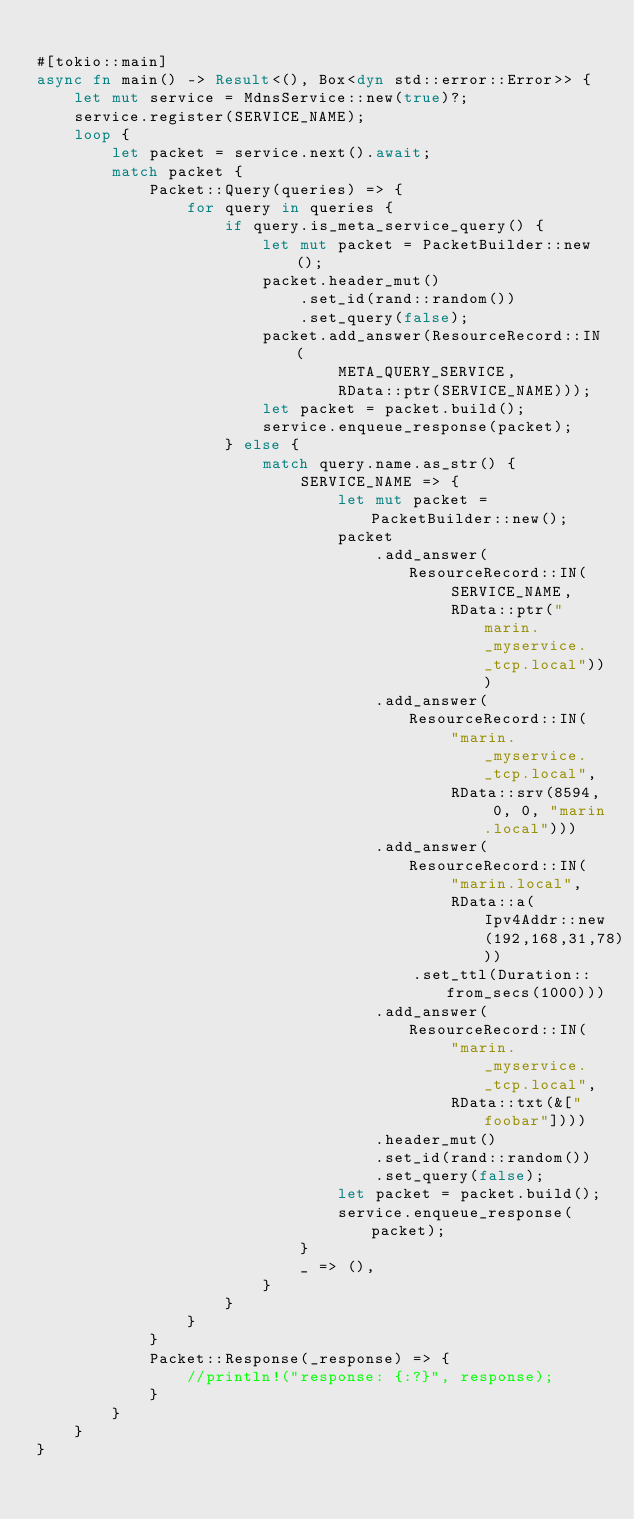Convert code to text. <code><loc_0><loc_0><loc_500><loc_500><_Rust_>
#[tokio::main]
async fn main() -> Result<(), Box<dyn std::error::Error>> {
    let mut service = MdnsService::new(true)?;
    service.register(SERVICE_NAME);
    loop {
        let packet = service.next().await;
        match packet {
            Packet::Query(queries) => {
                for query in queries {
                    if query.is_meta_service_query() {
                        let mut packet = PacketBuilder::new();
                        packet.header_mut()
                            .set_id(rand::random())
                            .set_query(false);
                        packet.add_answer(ResourceRecord::IN(
                                META_QUERY_SERVICE,
                                RData::ptr(SERVICE_NAME)));
                        let packet = packet.build();
                        service.enqueue_response(packet);
                    } else {
                        match query.name.as_str() {
                            SERVICE_NAME => {
                                let mut packet = PacketBuilder::new();
                                packet
                                    .add_answer(ResourceRecord::IN(
                                            SERVICE_NAME,
                                            RData::ptr("marin._myservice._tcp.local")))
                                    .add_answer(ResourceRecord::IN(
                                            "marin._myservice._tcp.local",
                                            RData::srv(8594, 0, 0, "marin.local")))
                                    .add_answer(ResourceRecord::IN(
                                            "marin.local",
                                            RData::a(Ipv4Addr::new(192,168,31,78)))
                                        .set_ttl(Duration::from_secs(1000)))
                                    .add_answer(ResourceRecord::IN(
                                            "marin._myservice._tcp.local",
                                            RData::txt(&["foobar"])))
                                    .header_mut()
                                    .set_id(rand::random())
                                    .set_query(false);
                                let packet = packet.build();
                                service.enqueue_response(packet);
                            }
                            _ => (),
                        }
                    }
                }
            }
            Packet::Response(_response) => {
                //println!("response: {:?}", response);
            }
        }
    }
}
</code> 